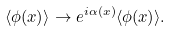<formula> <loc_0><loc_0><loc_500><loc_500>\langle \phi ( x ) \rangle \rightarrow e ^ { i \alpha ( x ) } \langle \phi ( x ) \rangle .</formula> 